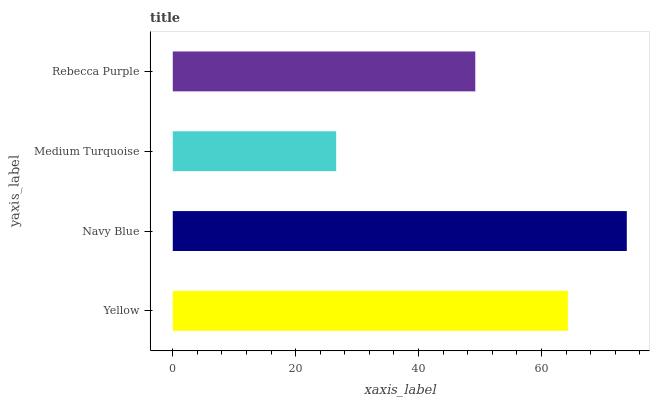Is Medium Turquoise the minimum?
Answer yes or no. Yes. Is Navy Blue the maximum?
Answer yes or no. Yes. Is Navy Blue the minimum?
Answer yes or no. No. Is Medium Turquoise the maximum?
Answer yes or no. No. Is Navy Blue greater than Medium Turquoise?
Answer yes or no. Yes. Is Medium Turquoise less than Navy Blue?
Answer yes or no. Yes. Is Medium Turquoise greater than Navy Blue?
Answer yes or no. No. Is Navy Blue less than Medium Turquoise?
Answer yes or no. No. Is Yellow the high median?
Answer yes or no. Yes. Is Rebecca Purple the low median?
Answer yes or no. Yes. Is Navy Blue the high median?
Answer yes or no. No. Is Navy Blue the low median?
Answer yes or no. No. 